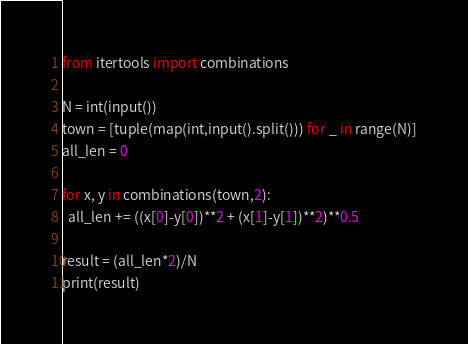<code> <loc_0><loc_0><loc_500><loc_500><_Python_>from itertools import combinations

N = int(input())
town = [tuple(map(int,input().split())) for _ in range(N)]
all_len = 0

for x, y in combinations(town,2):
  all_len += ((x[0]-y[0])**2 + (x[1]-y[1])**2)**0.5

result = (all_len*2)/N
print(result)</code> 